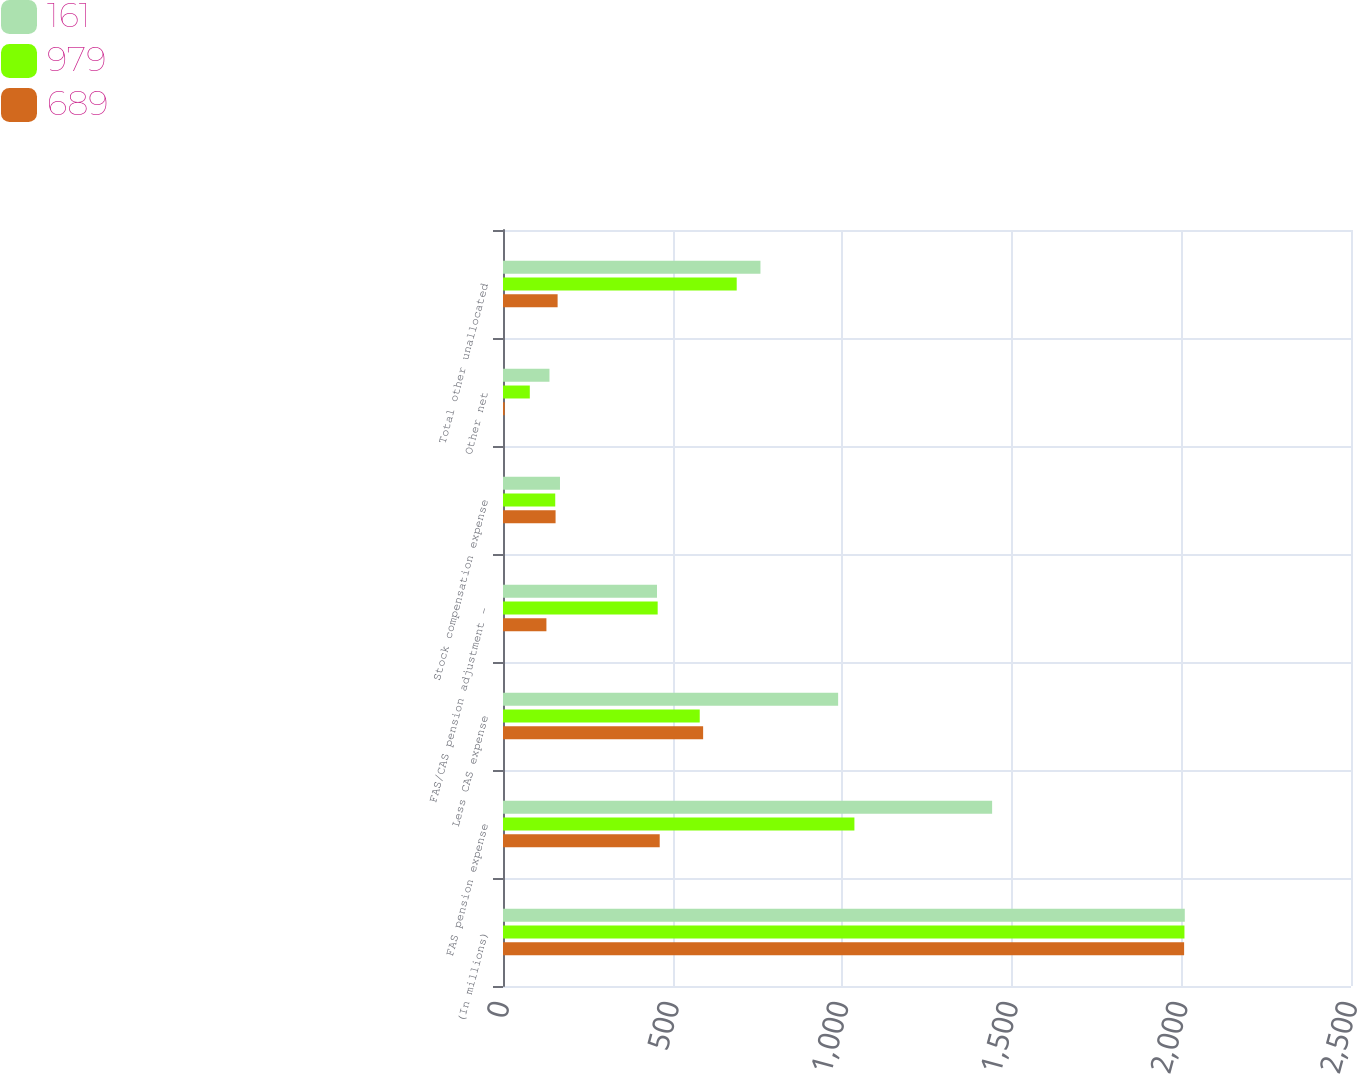Convert chart. <chart><loc_0><loc_0><loc_500><loc_500><stacked_bar_chart><ecel><fcel>(In millions)<fcel>FAS pension expense<fcel>Less CAS expense<fcel>FAS/CAS pension adjustment -<fcel>Stock compensation expense<fcel>Other net<fcel>Total other unallocated<nl><fcel>161<fcel>2010<fcel>1442<fcel>988<fcel>454<fcel>168<fcel>137<fcel>759<nl><fcel>979<fcel>2009<fcel>1036<fcel>580<fcel>456<fcel>154<fcel>79<fcel>689<nl><fcel>689<fcel>2008<fcel>462<fcel>590<fcel>128<fcel>155<fcel>5<fcel>161<nl></chart> 